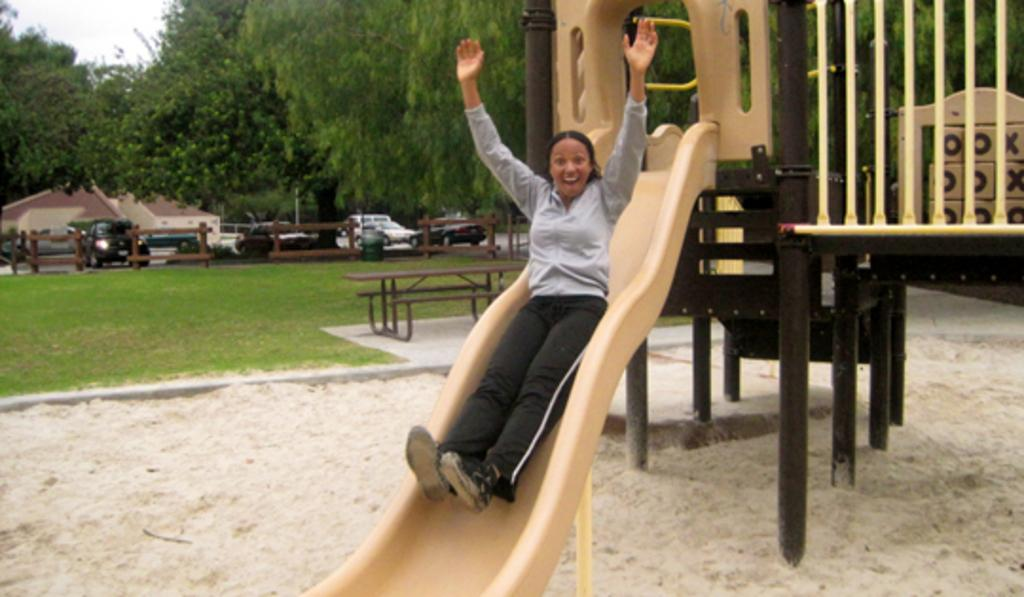What is the person in the image doing? There is a person on a slide in the image. What type of surface is visible beneath the person on the slide? There is grass in the image. What type of seating is present in the image? There is a bench in the image. What type of barrier is present in the image? There is fencing in the image. What type of transportation is visible in the image? There are vehicles in the image. What type of vegetation is present in the image? There are trees in the image. What type of robin can be seen eating rice in the image? There is no robin or rice present in the image. What type of connection can be seen between the person on the slide and the vehicles in the image? There is no direct connection between the person on the slide and the vehicles in the image. 